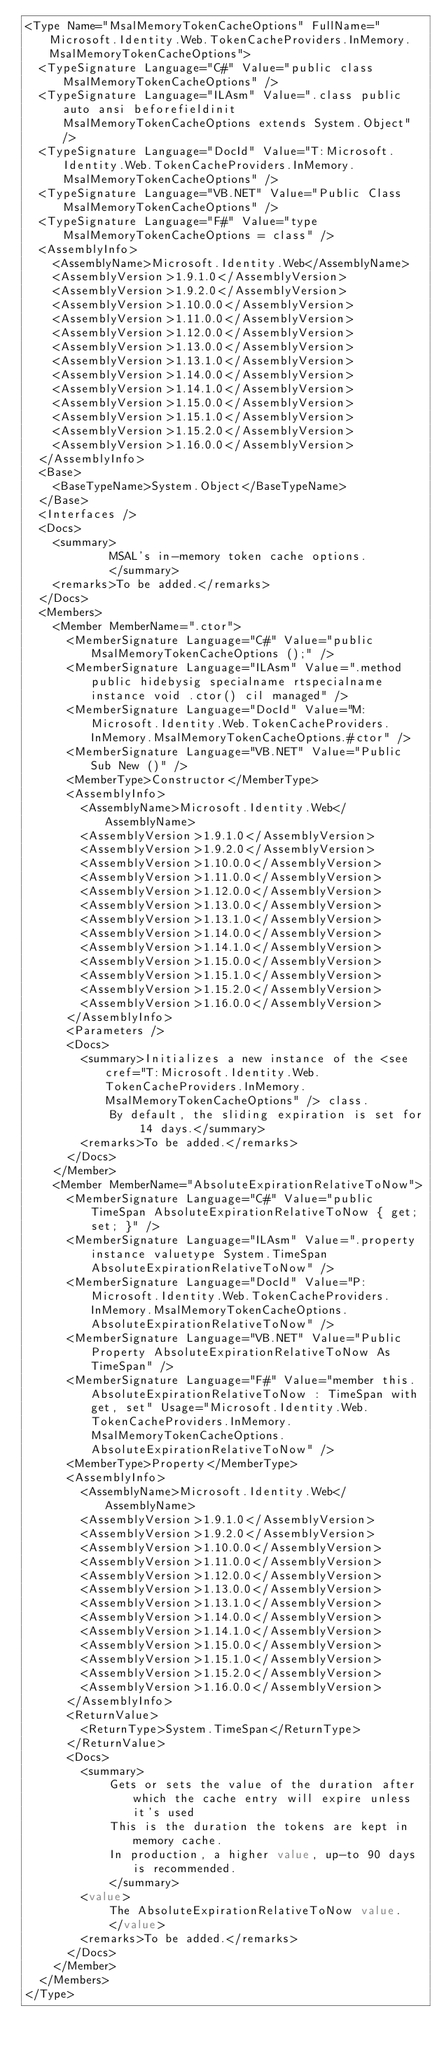<code> <loc_0><loc_0><loc_500><loc_500><_XML_><Type Name="MsalMemoryTokenCacheOptions" FullName="Microsoft.Identity.Web.TokenCacheProviders.InMemory.MsalMemoryTokenCacheOptions">
  <TypeSignature Language="C#" Value="public class MsalMemoryTokenCacheOptions" />
  <TypeSignature Language="ILAsm" Value=".class public auto ansi beforefieldinit MsalMemoryTokenCacheOptions extends System.Object" />
  <TypeSignature Language="DocId" Value="T:Microsoft.Identity.Web.TokenCacheProviders.InMemory.MsalMemoryTokenCacheOptions" />
  <TypeSignature Language="VB.NET" Value="Public Class MsalMemoryTokenCacheOptions" />
  <TypeSignature Language="F#" Value="type MsalMemoryTokenCacheOptions = class" />
  <AssemblyInfo>
    <AssemblyName>Microsoft.Identity.Web</AssemblyName>
    <AssemblyVersion>1.9.1.0</AssemblyVersion>
    <AssemblyVersion>1.9.2.0</AssemblyVersion>
    <AssemblyVersion>1.10.0.0</AssemblyVersion>
    <AssemblyVersion>1.11.0.0</AssemblyVersion>
    <AssemblyVersion>1.12.0.0</AssemblyVersion>
    <AssemblyVersion>1.13.0.0</AssemblyVersion>
    <AssemblyVersion>1.13.1.0</AssemblyVersion>
    <AssemblyVersion>1.14.0.0</AssemblyVersion>
    <AssemblyVersion>1.14.1.0</AssemblyVersion>
    <AssemblyVersion>1.15.0.0</AssemblyVersion>
    <AssemblyVersion>1.15.1.0</AssemblyVersion>
    <AssemblyVersion>1.15.2.0</AssemblyVersion>
    <AssemblyVersion>1.16.0.0</AssemblyVersion>
  </AssemblyInfo>
  <Base>
    <BaseTypeName>System.Object</BaseTypeName>
  </Base>
  <Interfaces />
  <Docs>
    <summary>
            MSAL's in-memory token cache options.
            </summary>
    <remarks>To be added.</remarks>
  </Docs>
  <Members>
    <Member MemberName=".ctor">
      <MemberSignature Language="C#" Value="public MsalMemoryTokenCacheOptions ();" />
      <MemberSignature Language="ILAsm" Value=".method public hidebysig specialname rtspecialname instance void .ctor() cil managed" />
      <MemberSignature Language="DocId" Value="M:Microsoft.Identity.Web.TokenCacheProviders.InMemory.MsalMemoryTokenCacheOptions.#ctor" />
      <MemberSignature Language="VB.NET" Value="Public Sub New ()" />
      <MemberType>Constructor</MemberType>
      <AssemblyInfo>
        <AssemblyName>Microsoft.Identity.Web</AssemblyName>
        <AssemblyVersion>1.9.1.0</AssemblyVersion>
        <AssemblyVersion>1.9.2.0</AssemblyVersion>
        <AssemblyVersion>1.10.0.0</AssemblyVersion>
        <AssemblyVersion>1.11.0.0</AssemblyVersion>
        <AssemblyVersion>1.12.0.0</AssemblyVersion>
        <AssemblyVersion>1.13.0.0</AssemblyVersion>
        <AssemblyVersion>1.13.1.0</AssemblyVersion>
        <AssemblyVersion>1.14.0.0</AssemblyVersion>
        <AssemblyVersion>1.14.1.0</AssemblyVersion>
        <AssemblyVersion>1.15.0.0</AssemblyVersion>
        <AssemblyVersion>1.15.1.0</AssemblyVersion>
        <AssemblyVersion>1.15.2.0</AssemblyVersion>
        <AssemblyVersion>1.16.0.0</AssemblyVersion>
      </AssemblyInfo>
      <Parameters />
      <Docs>
        <summary>Initializes a new instance of the <see cref="T:Microsoft.Identity.Web.TokenCacheProviders.InMemory.MsalMemoryTokenCacheOptions" /> class.
            By default, the sliding expiration is set for 14 days.</summary>
        <remarks>To be added.</remarks>
      </Docs>
    </Member>
    <Member MemberName="AbsoluteExpirationRelativeToNow">
      <MemberSignature Language="C#" Value="public TimeSpan AbsoluteExpirationRelativeToNow { get; set; }" />
      <MemberSignature Language="ILAsm" Value=".property instance valuetype System.TimeSpan AbsoluteExpirationRelativeToNow" />
      <MemberSignature Language="DocId" Value="P:Microsoft.Identity.Web.TokenCacheProviders.InMemory.MsalMemoryTokenCacheOptions.AbsoluteExpirationRelativeToNow" />
      <MemberSignature Language="VB.NET" Value="Public Property AbsoluteExpirationRelativeToNow As TimeSpan" />
      <MemberSignature Language="F#" Value="member this.AbsoluteExpirationRelativeToNow : TimeSpan with get, set" Usage="Microsoft.Identity.Web.TokenCacheProviders.InMemory.MsalMemoryTokenCacheOptions.AbsoluteExpirationRelativeToNow" />
      <MemberType>Property</MemberType>
      <AssemblyInfo>
        <AssemblyName>Microsoft.Identity.Web</AssemblyName>
        <AssemblyVersion>1.9.1.0</AssemblyVersion>
        <AssemblyVersion>1.9.2.0</AssemblyVersion>
        <AssemblyVersion>1.10.0.0</AssemblyVersion>
        <AssemblyVersion>1.11.0.0</AssemblyVersion>
        <AssemblyVersion>1.12.0.0</AssemblyVersion>
        <AssemblyVersion>1.13.0.0</AssemblyVersion>
        <AssemblyVersion>1.13.1.0</AssemblyVersion>
        <AssemblyVersion>1.14.0.0</AssemblyVersion>
        <AssemblyVersion>1.14.1.0</AssemblyVersion>
        <AssemblyVersion>1.15.0.0</AssemblyVersion>
        <AssemblyVersion>1.15.1.0</AssemblyVersion>
        <AssemblyVersion>1.15.2.0</AssemblyVersion>
        <AssemblyVersion>1.16.0.0</AssemblyVersion>
      </AssemblyInfo>
      <ReturnValue>
        <ReturnType>System.TimeSpan</ReturnType>
      </ReturnValue>
      <Docs>
        <summary>
            Gets or sets the value of the duration after which the cache entry will expire unless it's used
            This is the duration the tokens are kept in memory cache.
            In production, a higher value, up-to 90 days is recommended.
            </summary>
        <value>
            The AbsoluteExpirationRelativeToNow value.
            </value>
        <remarks>To be added.</remarks>
      </Docs>
    </Member>
  </Members>
</Type>
</code> 